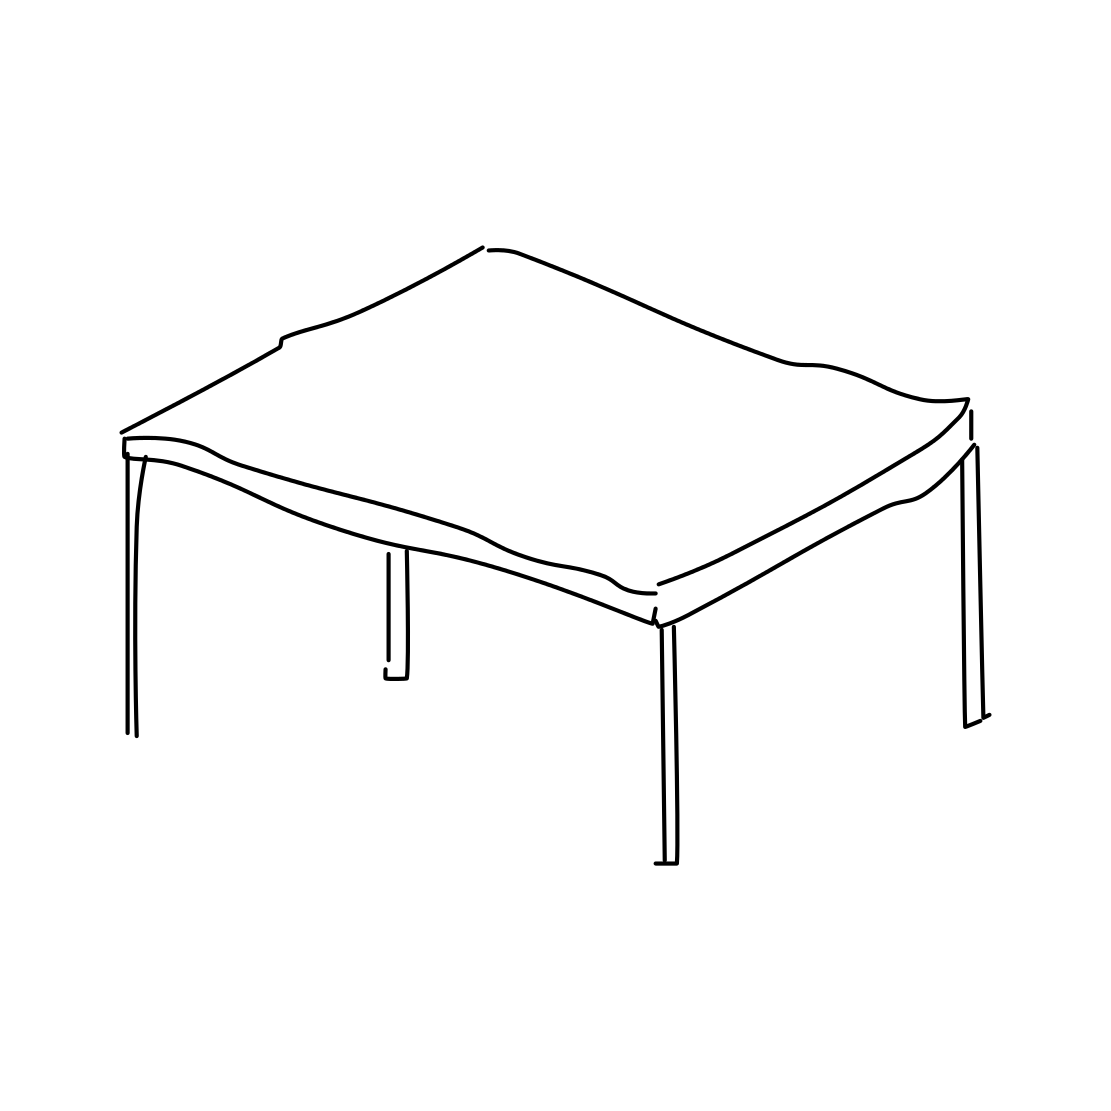What kind of room would this table fit best in? The table's simple and unadorned style would make it quite versatile. It could fit seamlessly into a modern office setting or a sparsely decorated room, emphasizing function and form. It's an excellent piece for spaces that favor a minimalist aesthetic.  What could be the function of such a table? This style of table is commonly used for a variety of purposes. It could serve as a dining table, a desk in a home office, or a surface for displaying items in a gallery or retail environment. The simplicity of its form opens up many possibilities for function. 